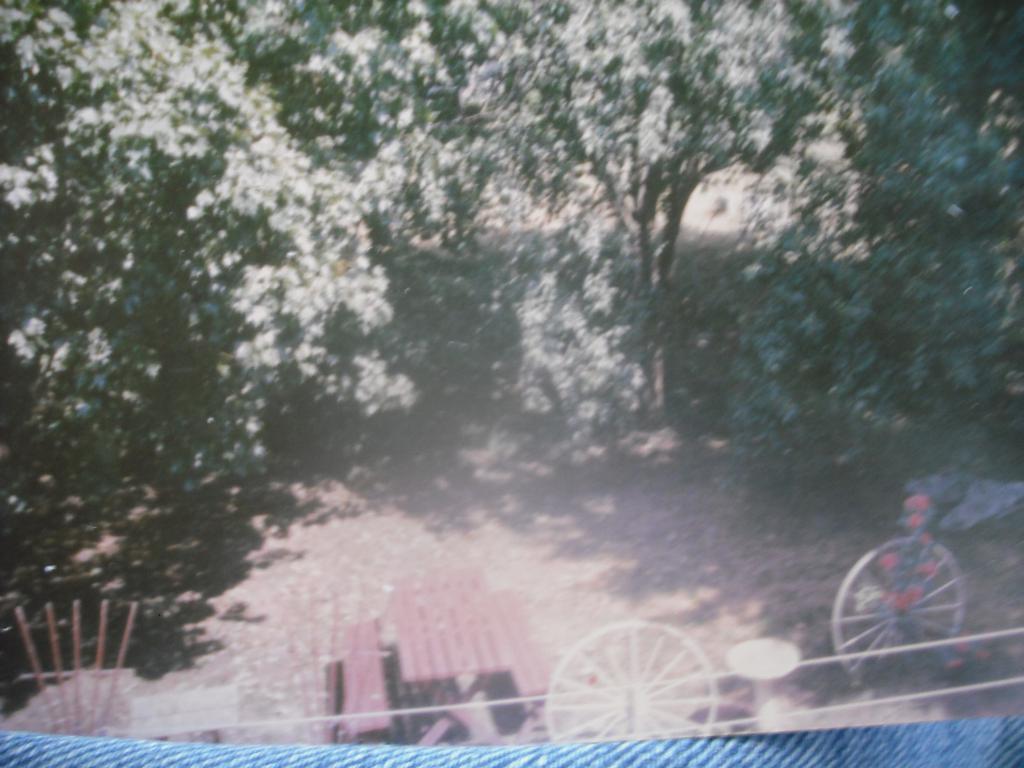How would you summarize this image in a sentence or two? In the image we can see trees, wooden benches and table, and two wheels. 